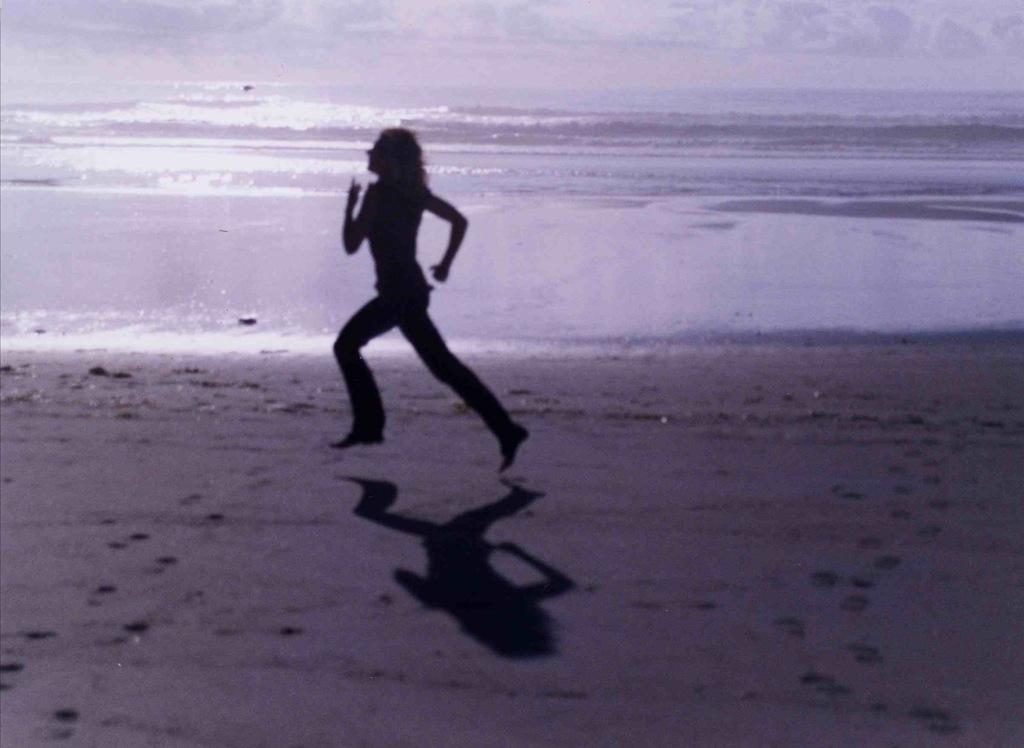Who is present in the image? There is a woman in the image. What is the woman doing in the image? The woman is running on the ground. What can be seen in the background of the image? There is water visible in the image. What type of cap is the woman wearing in the image? There is no cap visible in the image. 